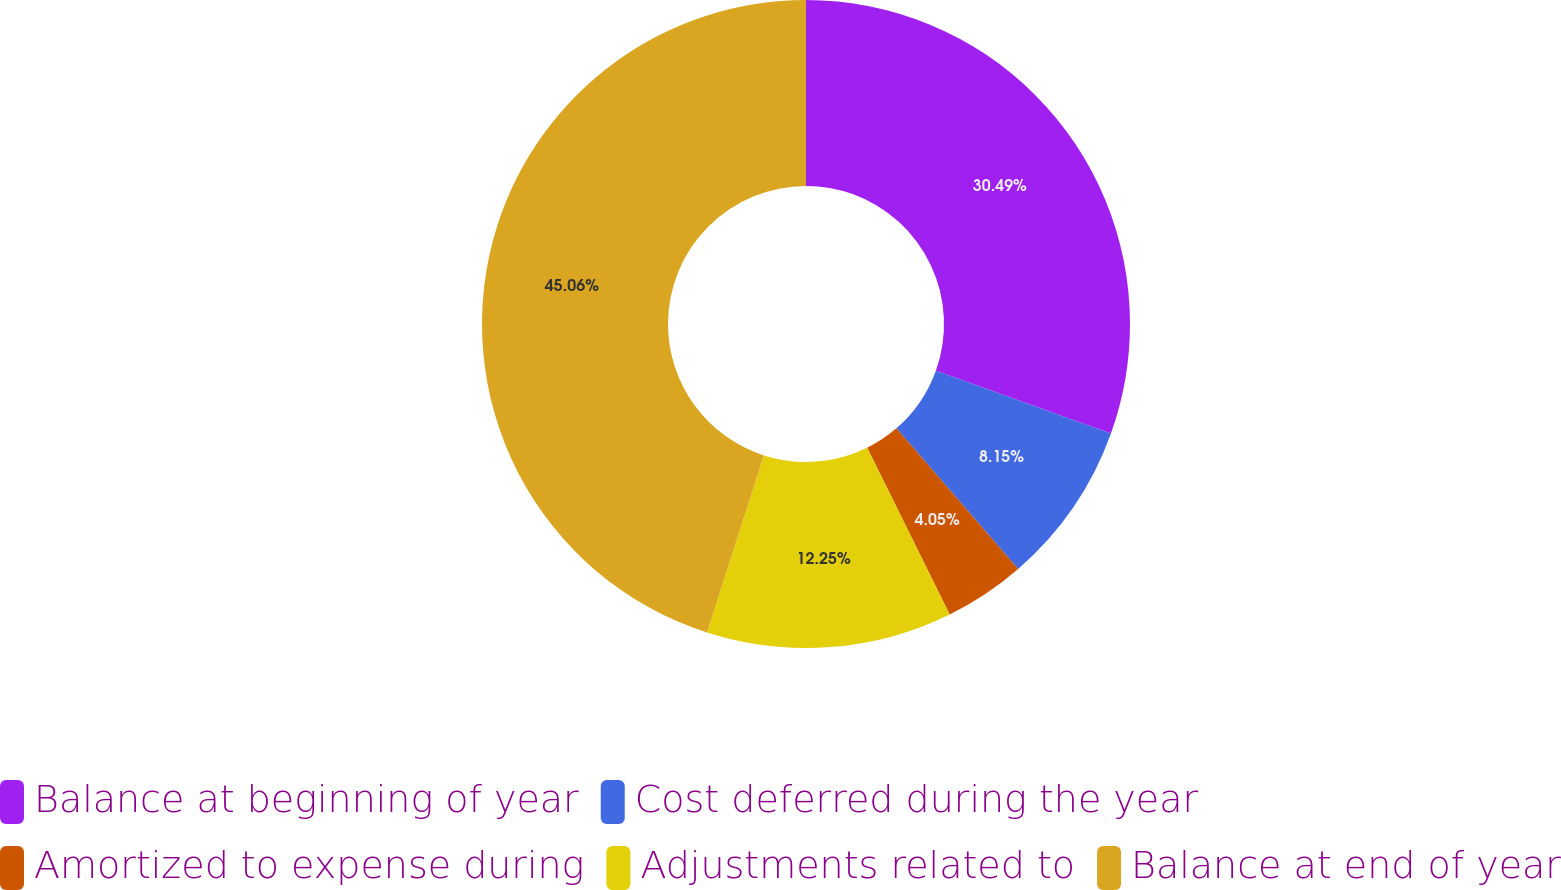<chart> <loc_0><loc_0><loc_500><loc_500><pie_chart><fcel>Balance at beginning of year<fcel>Cost deferred during the year<fcel>Amortized to expense during<fcel>Adjustments related to<fcel>Balance at end of year<nl><fcel>30.48%<fcel>8.15%<fcel>4.05%<fcel>12.25%<fcel>45.05%<nl></chart> 